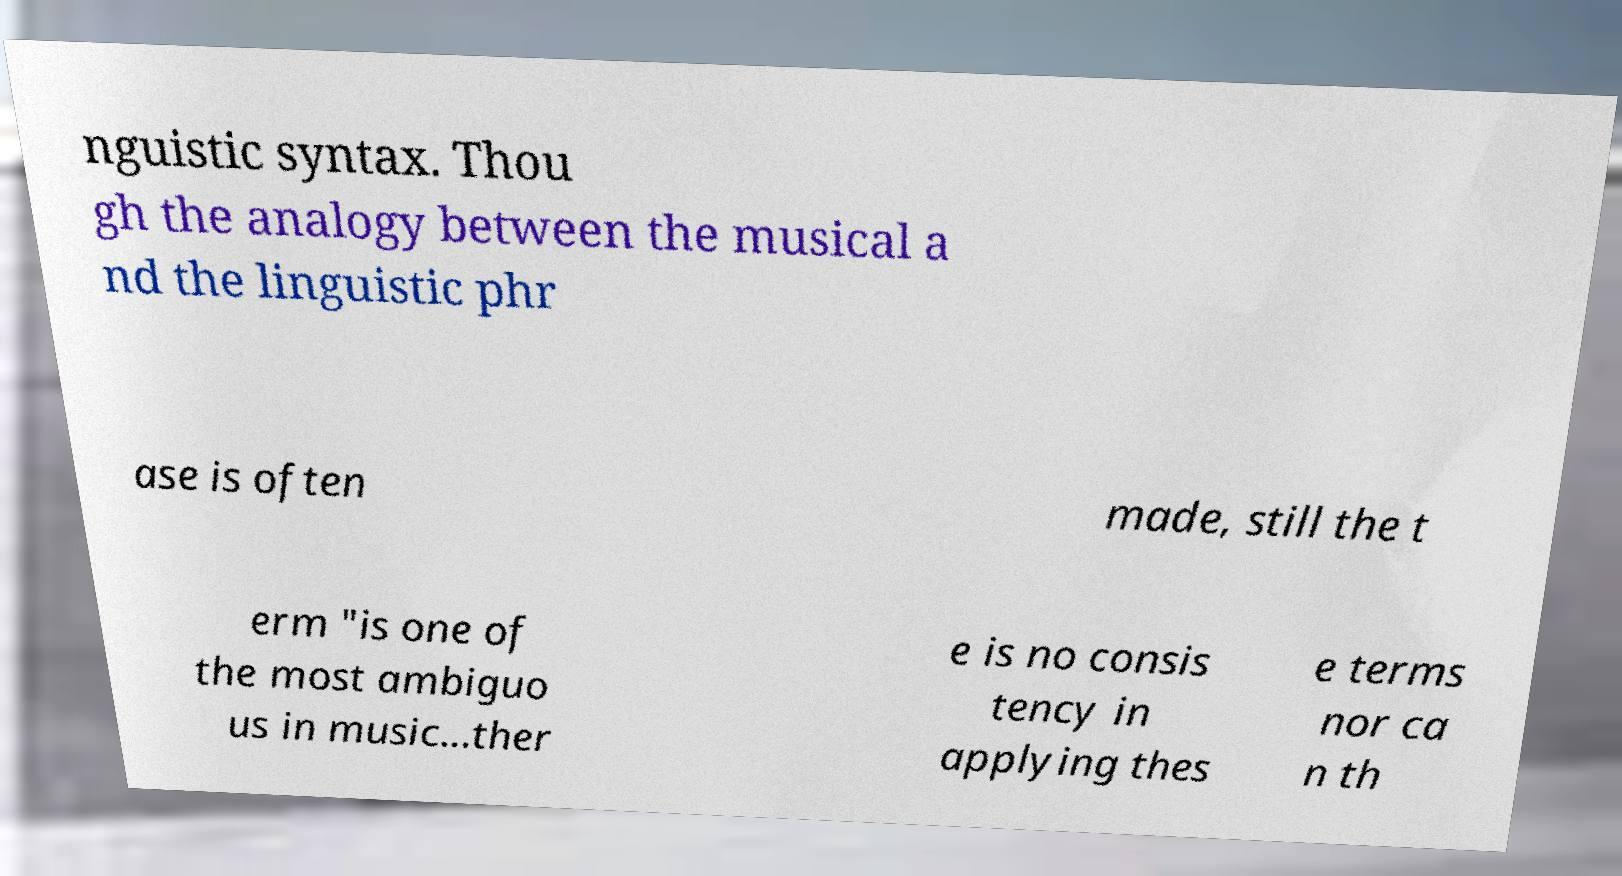For documentation purposes, I need the text within this image transcribed. Could you provide that? nguistic syntax. Thou gh the analogy between the musical a nd the linguistic phr ase is often made, still the t erm "is one of the most ambiguo us in music...ther e is no consis tency in applying thes e terms nor ca n th 